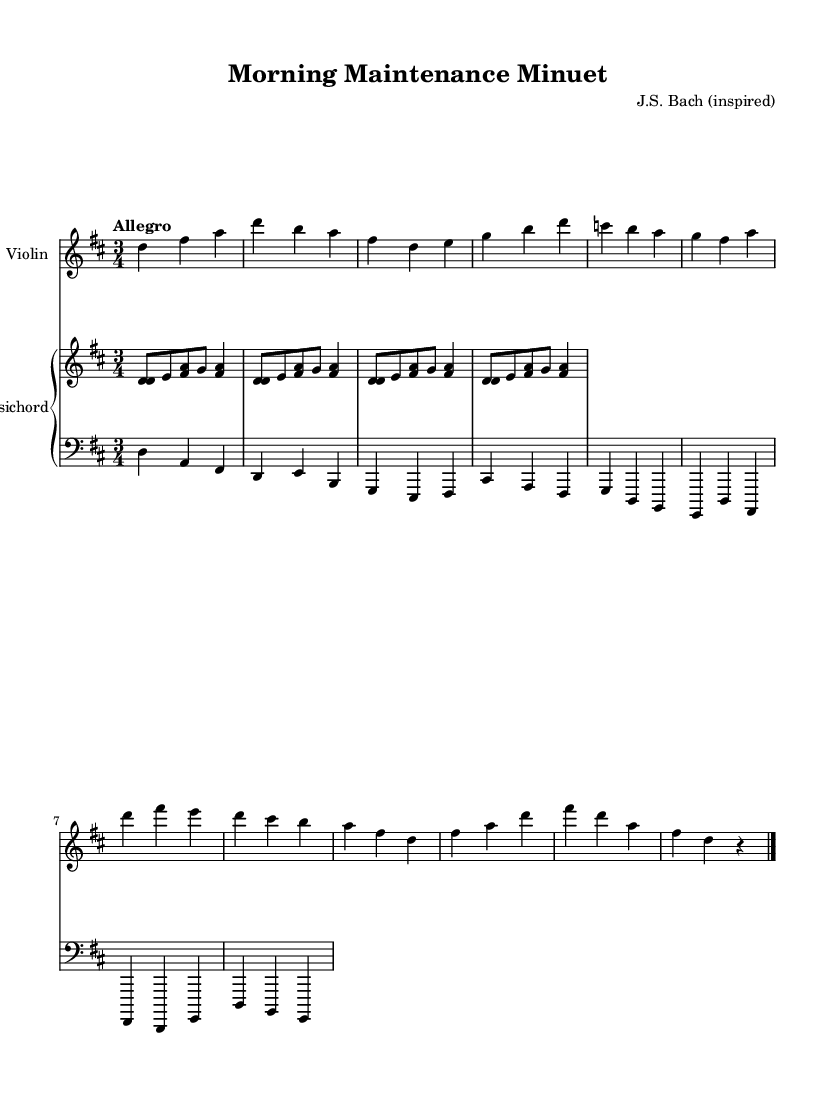What is the key signature of this music? The key signature indicated in the music is D major, which contains two sharps. These are A sharp and F sharp. This is determined by the presence of the sharp symbols placed on the staff lines corresponding to these notes.
Answer: D major What is the time signature of this music? The time signature of this piece is indicated as 3/4, which means there are three beats in each measure and the quarter note receives one beat. This is observed at the beginning of the score where the two numbers are positioned.
Answer: 3/4 What is the tempo marking of this music? The tempo marking specified in the sheet music is "Allegro," which is a directive to perform the piece at a lively and fast pace, typical for upbeat baroque pieces. This is found near the beginning of the score where tempo markings are usually placed.
Answer: Allegro How many sections does the violin part consist of? The violin part features 10 distinct phrases that can be counted by analyzing the measures and notes shown in the sheet music. Each measure contains a sequence of notes that collectively represent a structured musical line.
Answer: 10 What musical style does this piece represent? This piece represents the Baroque style of music. This is determined by its characteristics such as the use of ornamentation, contrapuntal textures, and a lively tempo, which are typical elements of Baroque compositions.
Answer: Baroque Which instrument plays the bass line? The instrument that plays the bass line in this score is the cello. This can be identified as the cello part is written in the bass clef, which is standard for this instrument, and contains lower notes that support the harmonic structure of the piece.
Answer: Cello 